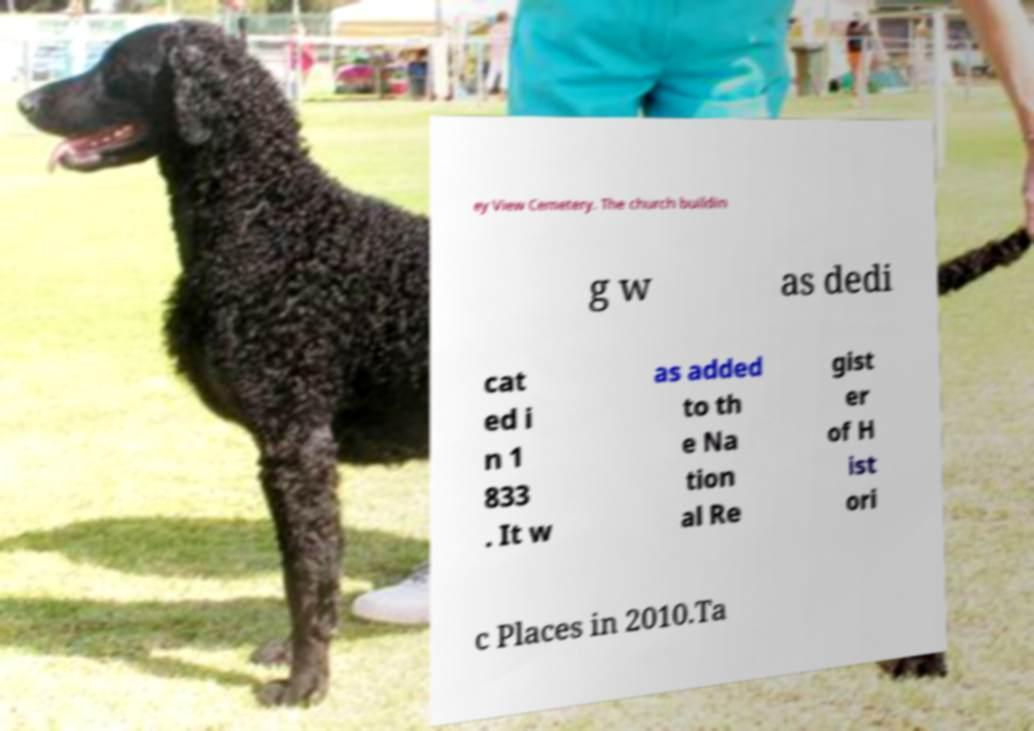Please read and relay the text visible in this image. What does it say? ey View Cemetery. The church buildin g w as dedi cat ed i n 1 833 . It w as added to th e Na tion al Re gist er of H ist ori c Places in 2010.Ta 